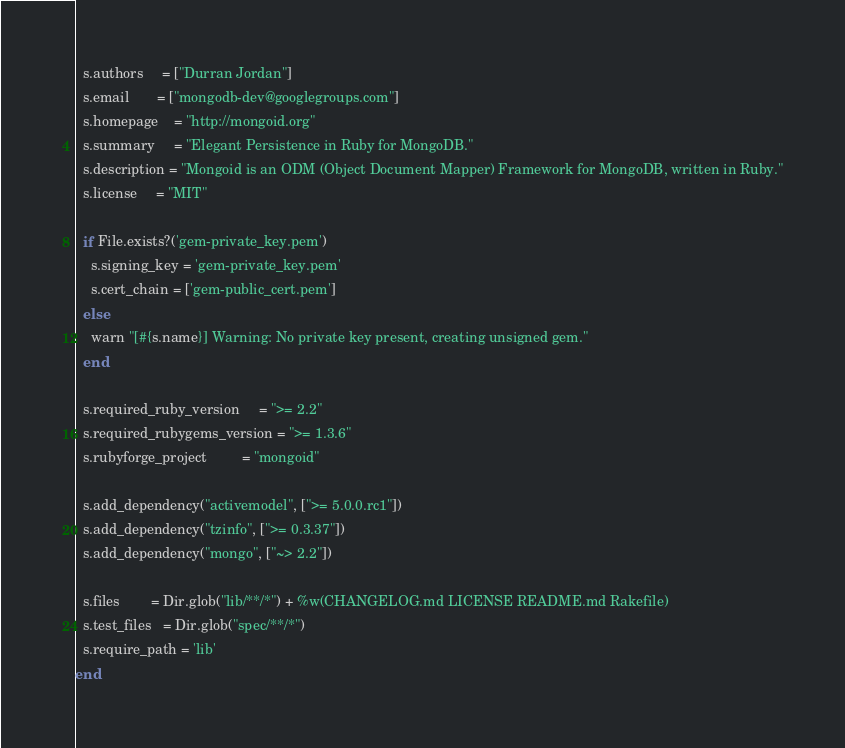Convert code to text. <code><loc_0><loc_0><loc_500><loc_500><_Ruby_>  s.authors     = ["Durran Jordan"]
  s.email       = ["mongodb-dev@googlegroups.com"]
  s.homepage    = "http://mongoid.org"
  s.summary     = "Elegant Persistence in Ruby for MongoDB."
  s.description = "Mongoid is an ODM (Object Document Mapper) Framework for MongoDB, written in Ruby."
  s.license     = "MIT"

  if File.exists?('gem-private_key.pem')
    s.signing_key = 'gem-private_key.pem'
    s.cert_chain = ['gem-public_cert.pem']
  else
    warn "[#{s.name}] Warning: No private key present, creating unsigned gem."
  end

  s.required_ruby_version     = ">= 2.2"
  s.required_rubygems_version = ">= 1.3.6"
  s.rubyforge_project         = "mongoid"

  s.add_dependency("activemodel", [">= 5.0.0.rc1"])
  s.add_dependency("tzinfo", [">= 0.3.37"])
  s.add_dependency("mongo", ["~> 2.2"])

  s.files        = Dir.glob("lib/**/*") + %w(CHANGELOG.md LICENSE README.md Rakefile)
  s.test_files   = Dir.glob("spec/**/*")
  s.require_path = 'lib'
end
</code> 